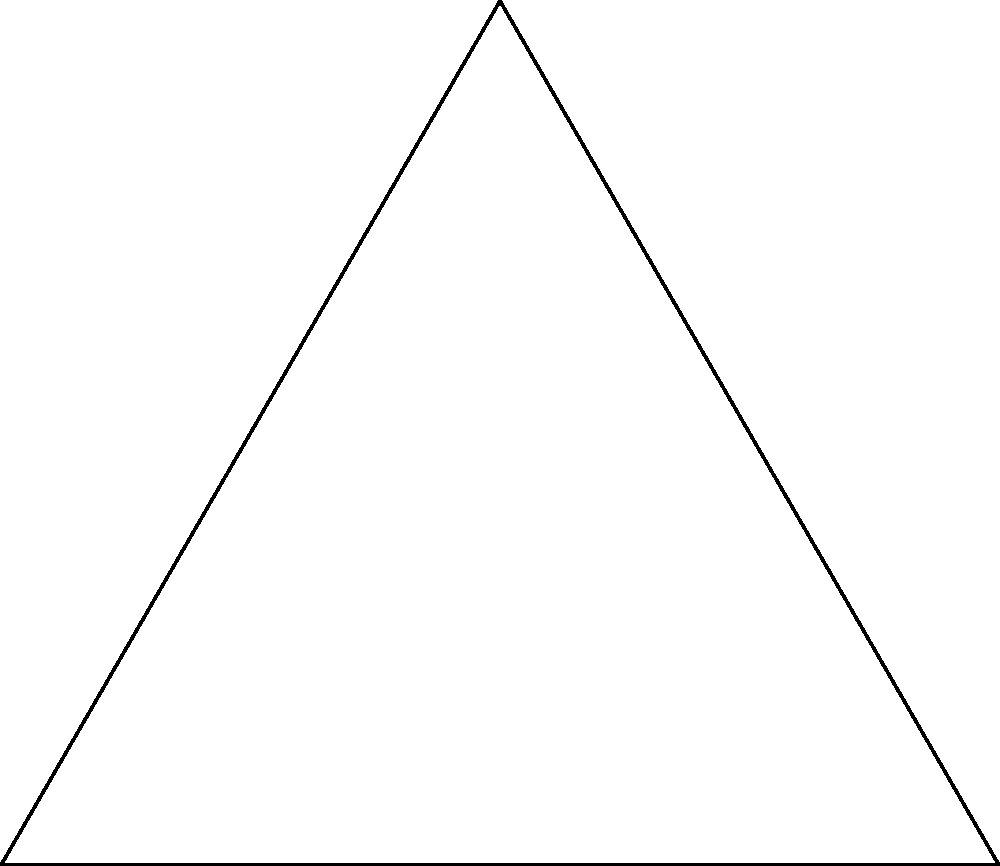In your new club setup, you've positioned two turntables and yourself in an equilateral triangle formation. If the angle between the two turntables from your position is 120°, what is the angle between your position and each turntable from the perspective of the other turntable? Let's approach this step-by-step:

1) In an equilateral triangle, all sides are equal and all angles are 60°.

2) We're given that the angle between the two turntables from your position is 120°. This means that the remaining angle of the triangle must be:

   $180° - 120° = 60°$

   This confirms that we indeed have an equilateral triangle.

3) In an equilateral triangle, all angles are equal. Therefore, each angle of the triangle is 60°.

4) The angle we're looking for is the angle between your position and one turntable, from the perspective of the other turntable. This is one of the angles of our equilateral triangle.

5) Therefore, the angle we're seeking is 60°.

This setup is reminiscent of your early days DJing in the small club, where optimal positioning was crucial for both sound quality and interaction with the crowd.
Answer: 60° 